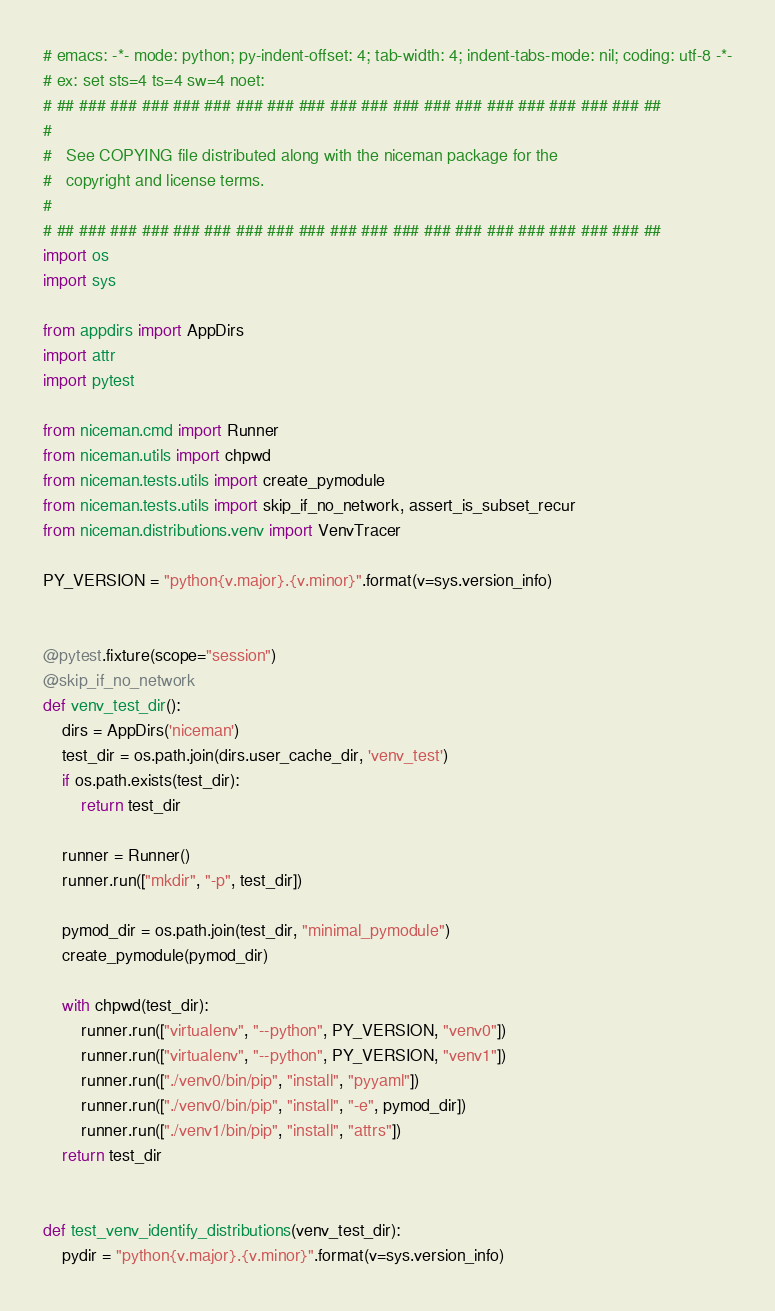Convert code to text. <code><loc_0><loc_0><loc_500><loc_500><_Python_># emacs: -*- mode: python; py-indent-offset: 4; tab-width: 4; indent-tabs-mode: nil; coding: utf-8 -*-
# ex: set sts=4 ts=4 sw=4 noet:
# ## ### ### ### ### ### ### ### ### ### ### ### ### ### ### ### ### ### ### ##
#
#   See COPYING file distributed along with the niceman package for the
#   copyright and license terms.
#
# ## ### ### ### ### ### ### ### ### ### ### ### ### ### ### ### ### ### ### ##
import os
import sys

from appdirs import AppDirs
import attr
import pytest

from niceman.cmd import Runner
from niceman.utils import chpwd
from niceman.tests.utils import create_pymodule
from niceman.tests.utils import skip_if_no_network, assert_is_subset_recur
from niceman.distributions.venv import VenvTracer

PY_VERSION = "python{v.major}.{v.minor}".format(v=sys.version_info)


@pytest.fixture(scope="session")
@skip_if_no_network
def venv_test_dir():
    dirs = AppDirs('niceman')
    test_dir = os.path.join(dirs.user_cache_dir, 'venv_test')
    if os.path.exists(test_dir):
        return test_dir

    runner = Runner()
    runner.run(["mkdir", "-p", test_dir])

    pymod_dir = os.path.join(test_dir, "minimal_pymodule")
    create_pymodule(pymod_dir)

    with chpwd(test_dir):
        runner.run(["virtualenv", "--python", PY_VERSION, "venv0"])
        runner.run(["virtualenv", "--python", PY_VERSION, "venv1"])
        runner.run(["./venv0/bin/pip", "install", "pyyaml"])
        runner.run(["./venv0/bin/pip", "install", "-e", pymod_dir])
        runner.run(["./venv1/bin/pip", "install", "attrs"])
    return test_dir


def test_venv_identify_distributions(venv_test_dir):
    pydir = "python{v.major}.{v.minor}".format(v=sys.version_info)</code> 